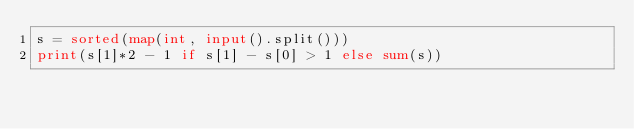Convert code to text. <code><loc_0><loc_0><loc_500><loc_500><_Python_>s = sorted(map(int, input().split()))
print(s[1]*2 - 1 if s[1] - s[0] > 1 else sum(s))</code> 